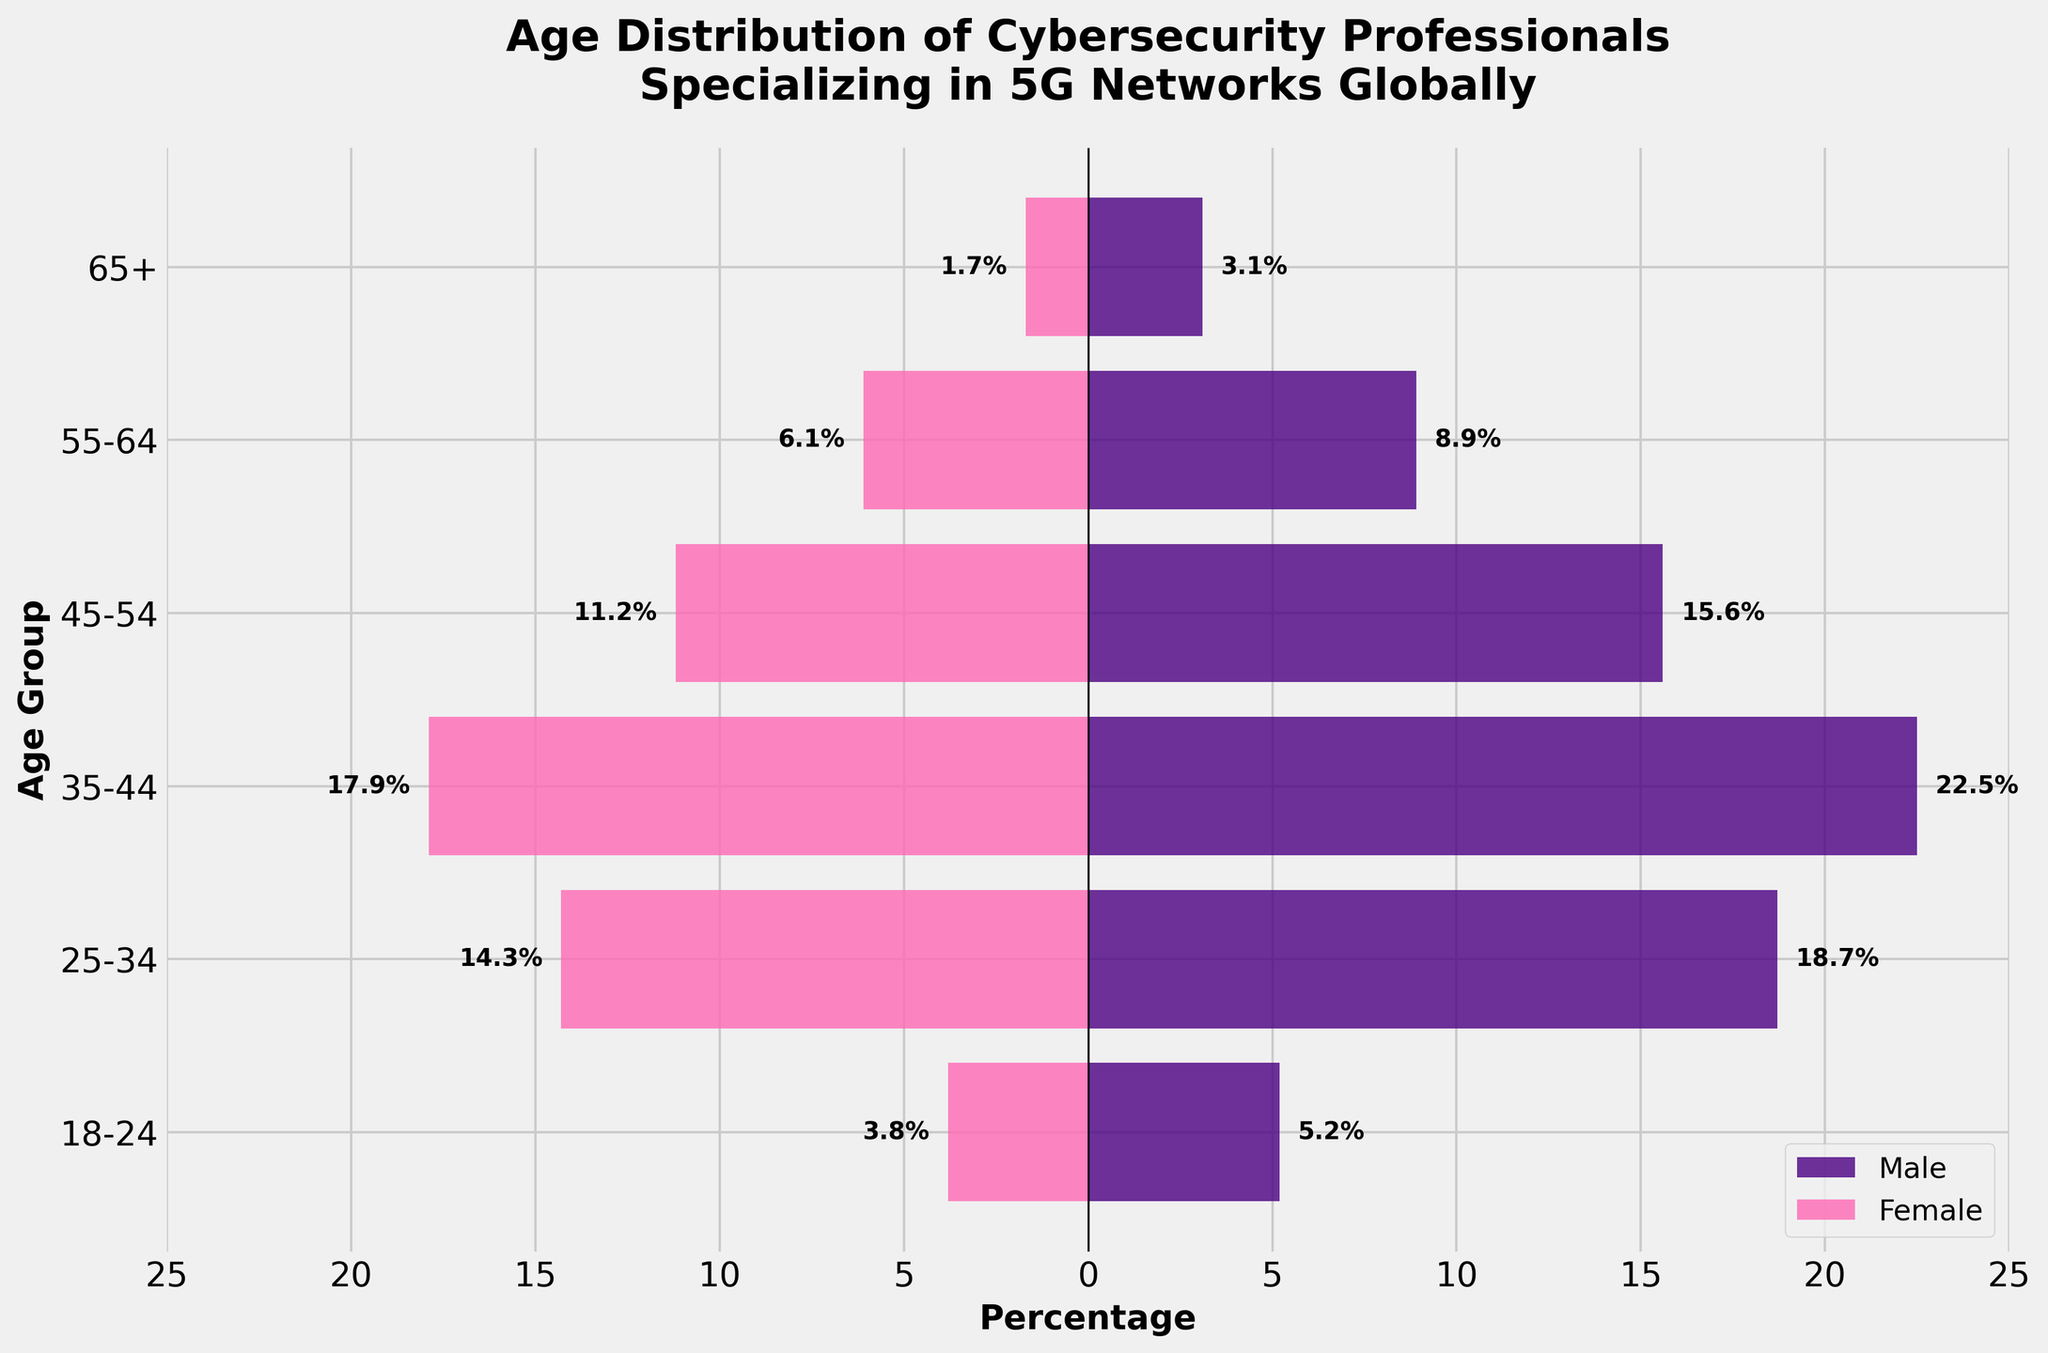What is the title of the plot? The title is located at the top of the figure, typically in a larger font size and bold.
Answer: Age Distribution of Cybersecurity Professionals Specializing in 5G Networks Globally Which gender has more professionals in the 25-34 age group? Compare the lengths of the bars for males and females in the 25-34 age row to see which is longer. The male percentage is 18.7%, while the female percentage is 14.3%.
Answer: Male What is the difference between the number of males and females in the 35-44 age group? Find the values of males (22.5%) and females (17.9%) in the 35-44 age group and subtract the female value from the male value: 22.5% - 17.9% = 4.6%.
Answer: 4.6% For which age group is the number of female professionals the lowest? Look for the smallest negative bar on the female side across all age groups. The 65+ age group has the lowest value at 1.7%.
Answer: 65+ Which age group has the closest number of male and female professionals? Compare the percentages of males and females for each age group by calculating the absolute difference. The 55-64 age group has males (8.9%) and females (6.1%) with the smallest difference, which is 2.8%.
Answer: 55-64 How does the percentage of female professionals in the 18-24 age group compare to that in the 45-54 age group? Compare the values for the female professionals in both age groups. The 18-24 age group has 3.8% females, and the 45-54 age group has 11.2% females. 3.8% is less than 11.2%.
Answer: Less What is the total percentage of cybersecurity professionals for the 35-44 age group? Sum the percentages of males (22.5%) and females (17.9%) in the 35-44 age group: 22.5% + 17.9% = 40.4%.
Answer: 40.4% What is the sum of male professionals in all age groups? Add the percentages for male professionals in all age groups: 5.2% + 18.7% + 22.5% + 15.6% + 8.9% + 3.1% = 74%.
Answer: 74% Which age group has the highest percentage of male professionals? Identify the age group with the longest bar on the male side. The 35-44 age group has the highest percentage at 22.5%.
Answer: 35-44 Is the distribution more balanced in younger or older age groups? Examine the differences between male and female bars across different age groups. Younger groups (e.g., 18-24) tend to have more balanced bars compared to older groups (e.g., 65+).
Answer: Younger 